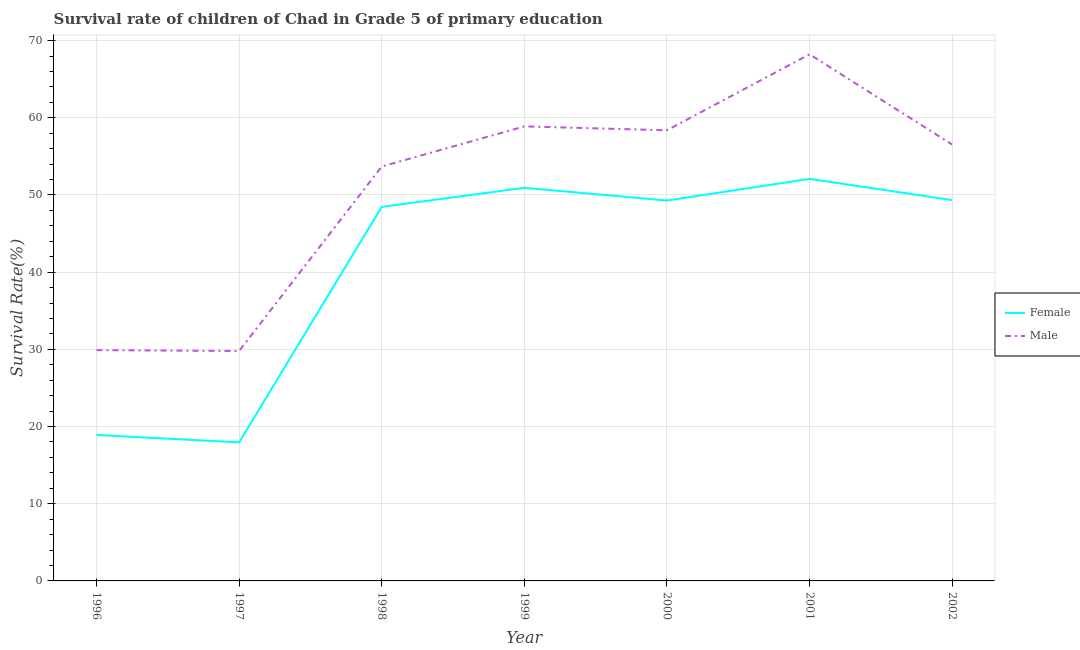Does the line corresponding to survival rate of female students in primary education intersect with the line corresponding to survival rate of male students in primary education?
Give a very brief answer. No. What is the survival rate of female students in primary education in 1999?
Provide a succinct answer. 50.93. Across all years, what is the maximum survival rate of female students in primary education?
Offer a terse response. 52.08. Across all years, what is the minimum survival rate of female students in primary education?
Offer a terse response. 17.95. What is the total survival rate of male students in primary education in the graph?
Provide a short and direct response. 355.37. What is the difference between the survival rate of female students in primary education in 1996 and that in 1999?
Your answer should be compact. -32.02. What is the difference between the survival rate of male students in primary education in 1997 and the survival rate of female students in primary education in 2000?
Provide a short and direct response. -19.49. What is the average survival rate of female students in primary education per year?
Keep it short and to the point. 40.99. In the year 2000, what is the difference between the survival rate of female students in primary education and survival rate of male students in primary education?
Offer a terse response. -9.1. In how many years, is the survival rate of male students in primary education greater than 44 %?
Your answer should be very brief. 5. What is the ratio of the survival rate of female students in primary education in 1996 to that in 2000?
Provide a succinct answer. 0.38. Is the survival rate of female students in primary education in 1998 less than that in 2001?
Provide a short and direct response. Yes. What is the difference between the highest and the second highest survival rate of female students in primary education?
Keep it short and to the point. 1.16. What is the difference between the highest and the lowest survival rate of female students in primary education?
Keep it short and to the point. 34.14. In how many years, is the survival rate of male students in primary education greater than the average survival rate of male students in primary education taken over all years?
Your answer should be very brief. 5. How many lines are there?
Ensure brevity in your answer.  2. How many years are there in the graph?
Make the answer very short. 7. Where does the legend appear in the graph?
Make the answer very short. Center right. What is the title of the graph?
Your response must be concise. Survival rate of children of Chad in Grade 5 of primary education. What is the label or title of the X-axis?
Your response must be concise. Year. What is the label or title of the Y-axis?
Offer a very short reply. Survival Rate(%). What is the Survival Rate(%) of Female in 1996?
Your answer should be compact. 18.91. What is the Survival Rate(%) of Male in 1996?
Offer a very short reply. 29.9. What is the Survival Rate(%) in Female in 1997?
Offer a terse response. 17.95. What is the Survival Rate(%) of Male in 1997?
Your answer should be compact. 29.78. What is the Survival Rate(%) in Female in 1998?
Keep it short and to the point. 48.46. What is the Survival Rate(%) in Male in 1998?
Provide a short and direct response. 53.68. What is the Survival Rate(%) of Female in 1999?
Ensure brevity in your answer.  50.93. What is the Survival Rate(%) of Male in 1999?
Offer a very short reply. 58.88. What is the Survival Rate(%) in Female in 2000?
Make the answer very short. 49.28. What is the Survival Rate(%) in Male in 2000?
Your answer should be very brief. 58.38. What is the Survival Rate(%) of Female in 2001?
Make the answer very short. 52.08. What is the Survival Rate(%) in Male in 2001?
Offer a terse response. 68.22. What is the Survival Rate(%) in Female in 2002?
Your answer should be compact. 49.33. What is the Survival Rate(%) of Male in 2002?
Provide a short and direct response. 56.52. Across all years, what is the maximum Survival Rate(%) of Female?
Give a very brief answer. 52.08. Across all years, what is the maximum Survival Rate(%) of Male?
Offer a terse response. 68.22. Across all years, what is the minimum Survival Rate(%) in Female?
Make the answer very short. 17.95. Across all years, what is the minimum Survival Rate(%) in Male?
Make the answer very short. 29.78. What is the total Survival Rate(%) in Female in the graph?
Your response must be concise. 286.93. What is the total Survival Rate(%) of Male in the graph?
Provide a short and direct response. 355.37. What is the difference between the Survival Rate(%) of Female in 1996 and that in 1997?
Your answer should be compact. 0.96. What is the difference between the Survival Rate(%) of Male in 1996 and that in 1997?
Give a very brief answer. 0.12. What is the difference between the Survival Rate(%) in Female in 1996 and that in 1998?
Make the answer very short. -29.55. What is the difference between the Survival Rate(%) of Male in 1996 and that in 1998?
Your answer should be very brief. -23.79. What is the difference between the Survival Rate(%) of Female in 1996 and that in 1999?
Keep it short and to the point. -32.02. What is the difference between the Survival Rate(%) in Male in 1996 and that in 1999?
Give a very brief answer. -28.98. What is the difference between the Survival Rate(%) in Female in 1996 and that in 2000?
Give a very brief answer. -30.37. What is the difference between the Survival Rate(%) of Male in 1996 and that in 2000?
Ensure brevity in your answer.  -28.48. What is the difference between the Survival Rate(%) of Female in 1996 and that in 2001?
Your response must be concise. -33.18. What is the difference between the Survival Rate(%) of Male in 1996 and that in 2001?
Offer a terse response. -38.33. What is the difference between the Survival Rate(%) in Female in 1996 and that in 2002?
Your response must be concise. -30.43. What is the difference between the Survival Rate(%) of Male in 1996 and that in 2002?
Give a very brief answer. -26.63. What is the difference between the Survival Rate(%) of Female in 1997 and that in 1998?
Make the answer very short. -30.51. What is the difference between the Survival Rate(%) in Male in 1997 and that in 1998?
Make the answer very short. -23.9. What is the difference between the Survival Rate(%) in Female in 1997 and that in 1999?
Provide a short and direct response. -32.98. What is the difference between the Survival Rate(%) in Male in 1997 and that in 1999?
Keep it short and to the point. -29.1. What is the difference between the Survival Rate(%) of Female in 1997 and that in 2000?
Your answer should be compact. -31.33. What is the difference between the Survival Rate(%) in Male in 1997 and that in 2000?
Your answer should be very brief. -28.6. What is the difference between the Survival Rate(%) of Female in 1997 and that in 2001?
Provide a succinct answer. -34.14. What is the difference between the Survival Rate(%) of Male in 1997 and that in 2001?
Keep it short and to the point. -38.44. What is the difference between the Survival Rate(%) in Female in 1997 and that in 2002?
Provide a succinct answer. -31.39. What is the difference between the Survival Rate(%) of Male in 1997 and that in 2002?
Keep it short and to the point. -26.74. What is the difference between the Survival Rate(%) in Female in 1998 and that in 1999?
Your answer should be compact. -2.47. What is the difference between the Survival Rate(%) of Male in 1998 and that in 1999?
Make the answer very short. -5.2. What is the difference between the Survival Rate(%) in Female in 1998 and that in 2000?
Offer a very short reply. -0.82. What is the difference between the Survival Rate(%) of Male in 1998 and that in 2000?
Provide a short and direct response. -4.7. What is the difference between the Survival Rate(%) in Female in 1998 and that in 2001?
Your answer should be compact. -3.63. What is the difference between the Survival Rate(%) of Male in 1998 and that in 2001?
Give a very brief answer. -14.54. What is the difference between the Survival Rate(%) of Female in 1998 and that in 2002?
Provide a succinct answer. -0.88. What is the difference between the Survival Rate(%) in Male in 1998 and that in 2002?
Your response must be concise. -2.84. What is the difference between the Survival Rate(%) of Female in 1999 and that in 2000?
Your answer should be compact. 1.65. What is the difference between the Survival Rate(%) of Male in 1999 and that in 2000?
Your response must be concise. 0.5. What is the difference between the Survival Rate(%) of Female in 1999 and that in 2001?
Keep it short and to the point. -1.16. What is the difference between the Survival Rate(%) of Male in 1999 and that in 2001?
Your response must be concise. -9.34. What is the difference between the Survival Rate(%) in Female in 1999 and that in 2002?
Keep it short and to the point. 1.59. What is the difference between the Survival Rate(%) of Male in 1999 and that in 2002?
Make the answer very short. 2.36. What is the difference between the Survival Rate(%) of Female in 2000 and that in 2001?
Offer a terse response. -2.81. What is the difference between the Survival Rate(%) of Male in 2000 and that in 2001?
Offer a terse response. -9.85. What is the difference between the Survival Rate(%) in Female in 2000 and that in 2002?
Provide a succinct answer. -0.06. What is the difference between the Survival Rate(%) of Male in 2000 and that in 2002?
Your answer should be compact. 1.85. What is the difference between the Survival Rate(%) in Female in 2001 and that in 2002?
Ensure brevity in your answer.  2.75. What is the difference between the Survival Rate(%) of Male in 2001 and that in 2002?
Make the answer very short. 11.7. What is the difference between the Survival Rate(%) of Female in 1996 and the Survival Rate(%) of Male in 1997?
Keep it short and to the point. -10.87. What is the difference between the Survival Rate(%) in Female in 1996 and the Survival Rate(%) in Male in 1998?
Your answer should be compact. -34.78. What is the difference between the Survival Rate(%) of Female in 1996 and the Survival Rate(%) of Male in 1999?
Your answer should be very brief. -39.97. What is the difference between the Survival Rate(%) in Female in 1996 and the Survival Rate(%) in Male in 2000?
Make the answer very short. -39.47. What is the difference between the Survival Rate(%) of Female in 1996 and the Survival Rate(%) of Male in 2001?
Provide a succinct answer. -49.32. What is the difference between the Survival Rate(%) in Female in 1996 and the Survival Rate(%) in Male in 2002?
Keep it short and to the point. -37.62. What is the difference between the Survival Rate(%) in Female in 1997 and the Survival Rate(%) in Male in 1998?
Ensure brevity in your answer.  -35.73. What is the difference between the Survival Rate(%) of Female in 1997 and the Survival Rate(%) of Male in 1999?
Your answer should be very brief. -40.93. What is the difference between the Survival Rate(%) of Female in 1997 and the Survival Rate(%) of Male in 2000?
Ensure brevity in your answer.  -40.43. What is the difference between the Survival Rate(%) of Female in 1997 and the Survival Rate(%) of Male in 2001?
Make the answer very short. -50.28. What is the difference between the Survival Rate(%) in Female in 1997 and the Survival Rate(%) in Male in 2002?
Offer a terse response. -38.58. What is the difference between the Survival Rate(%) in Female in 1998 and the Survival Rate(%) in Male in 1999?
Offer a very short reply. -10.43. What is the difference between the Survival Rate(%) in Female in 1998 and the Survival Rate(%) in Male in 2000?
Offer a very short reply. -9.92. What is the difference between the Survival Rate(%) of Female in 1998 and the Survival Rate(%) of Male in 2001?
Your answer should be very brief. -19.77. What is the difference between the Survival Rate(%) of Female in 1998 and the Survival Rate(%) of Male in 2002?
Make the answer very short. -8.07. What is the difference between the Survival Rate(%) in Female in 1999 and the Survival Rate(%) in Male in 2000?
Your answer should be very brief. -7.45. What is the difference between the Survival Rate(%) of Female in 1999 and the Survival Rate(%) of Male in 2001?
Ensure brevity in your answer.  -17.3. What is the difference between the Survival Rate(%) of Female in 1999 and the Survival Rate(%) of Male in 2002?
Offer a terse response. -5.6. What is the difference between the Survival Rate(%) in Female in 2000 and the Survival Rate(%) in Male in 2001?
Keep it short and to the point. -18.95. What is the difference between the Survival Rate(%) in Female in 2000 and the Survival Rate(%) in Male in 2002?
Provide a succinct answer. -7.25. What is the difference between the Survival Rate(%) of Female in 2001 and the Survival Rate(%) of Male in 2002?
Give a very brief answer. -4.44. What is the average Survival Rate(%) of Female per year?
Make the answer very short. 40.99. What is the average Survival Rate(%) of Male per year?
Provide a short and direct response. 50.77. In the year 1996, what is the difference between the Survival Rate(%) in Female and Survival Rate(%) in Male?
Make the answer very short. -10.99. In the year 1997, what is the difference between the Survival Rate(%) in Female and Survival Rate(%) in Male?
Keep it short and to the point. -11.83. In the year 1998, what is the difference between the Survival Rate(%) of Female and Survival Rate(%) of Male?
Your response must be concise. -5.23. In the year 1999, what is the difference between the Survival Rate(%) of Female and Survival Rate(%) of Male?
Keep it short and to the point. -7.95. In the year 2000, what is the difference between the Survival Rate(%) in Female and Survival Rate(%) in Male?
Keep it short and to the point. -9.1. In the year 2001, what is the difference between the Survival Rate(%) of Female and Survival Rate(%) of Male?
Keep it short and to the point. -16.14. In the year 2002, what is the difference between the Survival Rate(%) of Female and Survival Rate(%) of Male?
Provide a succinct answer. -7.19. What is the ratio of the Survival Rate(%) in Female in 1996 to that in 1997?
Ensure brevity in your answer.  1.05. What is the ratio of the Survival Rate(%) in Female in 1996 to that in 1998?
Give a very brief answer. 0.39. What is the ratio of the Survival Rate(%) in Male in 1996 to that in 1998?
Give a very brief answer. 0.56. What is the ratio of the Survival Rate(%) in Female in 1996 to that in 1999?
Ensure brevity in your answer.  0.37. What is the ratio of the Survival Rate(%) in Male in 1996 to that in 1999?
Offer a very short reply. 0.51. What is the ratio of the Survival Rate(%) in Female in 1996 to that in 2000?
Your answer should be compact. 0.38. What is the ratio of the Survival Rate(%) in Male in 1996 to that in 2000?
Offer a very short reply. 0.51. What is the ratio of the Survival Rate(%) in Female in 1996 to that in 2001?
Give a very brief answer. 0.36. What is the ratio of the Survival Rate(%) in Male in 1996 to that in 2001?
Ensure brevity in your answer.  0.44. What is the ratio of the Survival Rate(%) of Female in 1996 to that in 2002?
Make the answer very short. 0.38. What is the ratio of the Survival Rate(%) in Male in 1996 to that in 2002?
Provide a succinct answer. 0.53. What is the ratio of the Survival Rate(%) in Female in 1997 to that in 1998?
Your response must be concise. 0.37. What is the ratio of the Survival Rate(%) in Male in 1997 to that in 1998?
Provide a succinct answer. 0.55. What is the ratio of the Survival Rate(%) of Female in 1997 to that in 1999?
Give a very brief answer. 0.35. What is the ratio of the Survival Rate(%) in Male in 1997 to that in 1999?
Provide a succinct answer. 0.51. What is the ratio of the Survival Rate(%) of Female in 1997 to that in 2000?
Offer a very short reply. 0.36. What is the ratio of the Survival Rate(%) in Male in 1997 to that in 2000?
Ensure brevity in your answer.  0.51. What is the ratio of the Survival Rate(%) of Female in 1997 to that in 2001?
Your answer should be compact. 0.34. What is the ratio of the Survival Rate(%) in Male in 1997 to that in 2001?
Offer a very short reply. 0.44. What is the ratio of the Survival Rate(%) in Female in 1997 to that in 2002?
Offer a very short reply. 0.36. What is the ratio of the Survival Rate(%) in Male in 1997 to that in 2002?
Give a very brief answer. 0.53. What is the ratio of the Survival Rate(%) in Female in 1998 to that in 1999?
Provide a succinct answer. 0.95. What is the ratio of the Survival Rate(%) of Male in 1998 to that in 1999?
Offer a very short reply. 0.91. What is the ratio of the Survival Rate(%) of Female in 1998 to that in 2000?
Your answer should be compact. 0.98. What is the ratio of the Survival Rate(%) in Male in 1998 to that in 2000?
Ensure brevity in your answer.  0.92. What is the ratio of the Survival Rate(%) of Female in 1998 to that in 2001?
Your answer should be compact. 0.93. What is the ratio of the Survival Rate(%) in Male in 1998 to that in 2001?
Keep it short and to the point. 0.79. What is the ratio of the Survival Rate(%) of Female in 1998 to that in 2002?
Offer a terse response. 0.98. What is the ratio of the Survival Rate(%) of Male in 1998 to that in 2002?
Provide a short and direct response. 0.95. What is the ratio of the Survival Rate(%) in Female in 1999 to that in 2000?
Your response must be concise. 1.03. What is the ratio of the Survival Rate(%) in Male in 1999 to that in 2000?
Make the answer very short. 1.01. What is the ratio of the Survival Rate(%) in Female in 1999 to that in 2001?
Provide a short and direct response. 0.98. What is the ratio of the Survival Rate(%) in Male in 1999 to that in 2001?
Offer a very short reply. 0.86. What is the ratio of the Survival Rate(%) in Female in 1999 to that in 2002?
Your response must be concise. 1.03. What is the ratio of the Survival Rate(%) of Male in 1999 to that in 2002?
Keep it short and to the point. 1.04. What is the ratio of the Survival Rate(%) of Female in 2000 to that in 2001?
Offer a terse response. 0.95. What is the ratio of the Survival Rate(%) in Male in 2000 to that in 2001?
Offer a very short reply. 0.86. What is the ratio of the Survival Rate(%) of Male in 2000 to that in 2002?
Provide a succinct answer. 1.03. What is the ratio of the Survival Rate(%) in Female in 2001 to that in 2002?
Make the answer very short. 1.06. What is the ratio of the Survival Rate(%) in Male in 2001 to that in 2002?
Offer a terse response. 1.21. What is the difference between the highest and the second highest Survival Rate(%) of Female?
Your answer should be compact. 1.16. What is the difference between the highest and the second highest Survival Rate(%) in Male?
Provide a short and direct response. 9.34. What is the difference between the highest and the lowest Survival Rate(%) of Female?
Keep it short and to the point. 34.14. What is the difference between the highest and the lowest Survival Rate(%) in Male?
Offer a terse response. 38.44. 